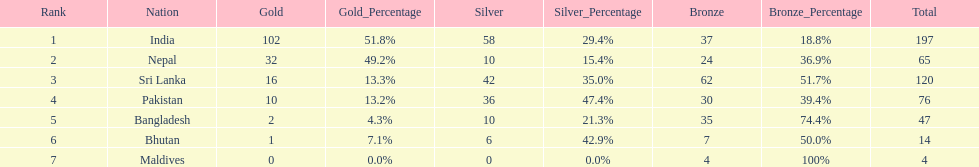How many countries have one more than 10 gold medals? 3. 